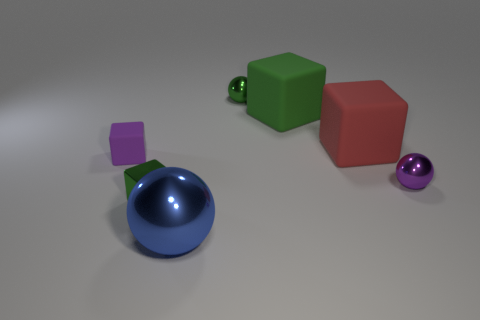Add 1 purple metallic spheres. How many objects exist? 8 Subtract all small purple shiny balls. How many balls are left? 2 Subtract all purple cubes. How many cubes are left? 3 Add 1 small green balls. How many small green balls exist? 2 Subtract 0 purple cylinders. How many objects are left? 7 Subtract all blocks. How many objects are left? 3 Subtract 2 cubes. How many cubes are left? 2 Subtract all green balls. Subtract all cyan cylinders. How many balls are left? 2 Subtract all gray cylinders. How many green balls are left? 1 Subtract all purple cylinders. Subtract all green objects. How many objects are left? 4 